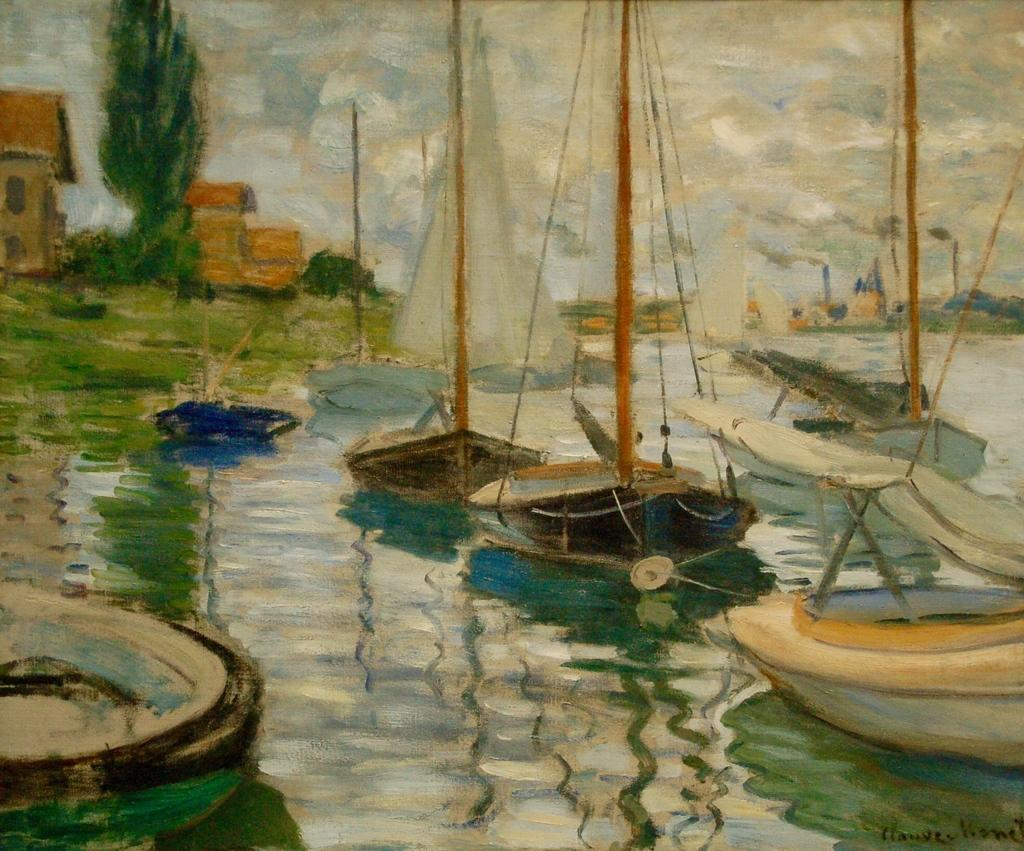What type of artwork is depicted in the image? The image is a painting. What body of water is present in the painting? There is a lake in the painting. What is in the lake? There are boats in the lake. What can be seen in the distance in the painting? There are trees and buildings in the background of the painting. What type of skate is being used by the person in the painting? There is no person or skate present in the painting; it features a lake, boats, trees, and buildings. What day of the week is depicted in the painting? The painting does not depict a specific day of the week; it is a general scene of a lake, boats, trees, and buildings. 